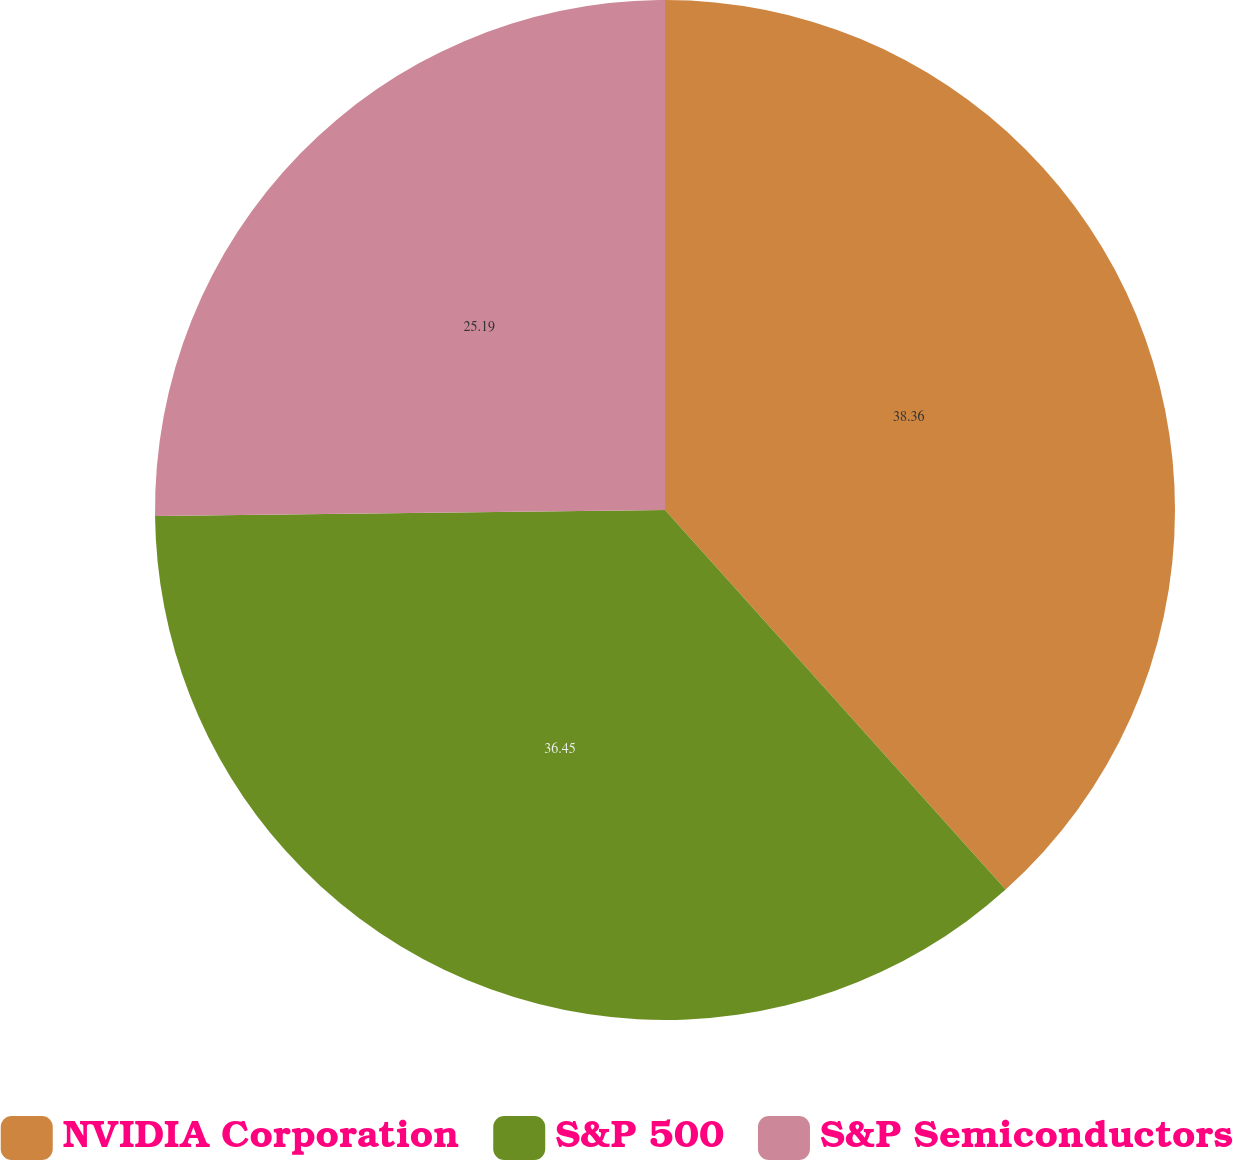Convert chart to OTSL. <chart><loc_0><loc_0><loc_500><loc_500><pie_chart><fcel>NVIDIA Corporation<fcel>S&P 500<fcel>S&P Semiconductors<nl><fcel>38.36%<fcel>36.45%<fcel>25.19%<nl></chart> 